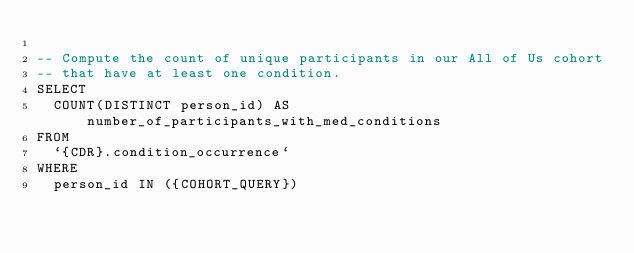Convert code to text. <code><loc_0><loc_0><loc_500><loc_500><_SQL_>
-- Compute the count of unique participants in our All of Us cohort
-- that have at least one condition.
SELECT
  COUNT(DISTINCT person_id) AS number_of_participants_with_med_conditions
FROM
  `{CDR}.condition_occurrence`
WHERE
  person_id IN ({COHORT_QUERY})
</code> 